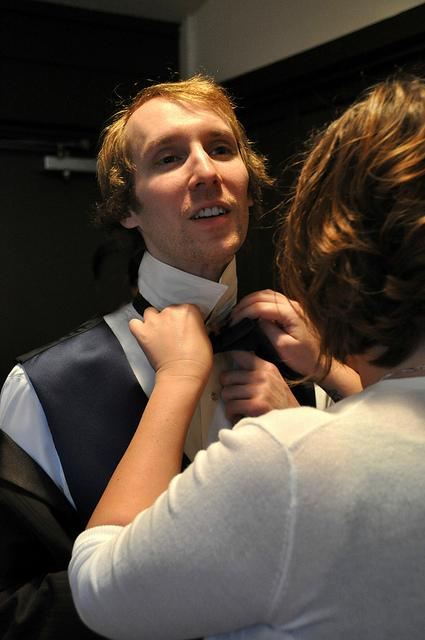What is the woman adjusting? Please explain your reasoning. tie. A woman is reaching towards a man's neck who is wearing dress clothes. ties are commonly wore as part of dress clothes for men. 